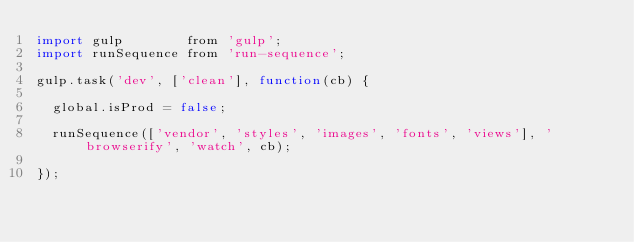Convert code to text. <code><loc_0><loc_0><loc_500><loc_500><_JavaScript_>import gulp        from 'gulp';
import runSequence from 'run-sequence';

gulp.task('dev', ['clean'], function(cb) {

  global.isProd = false;

  runSequence(['vendor', 'styles', 'images', 'fonts', 'views'], 'browserify', 'watch', cb);

});
</code> 